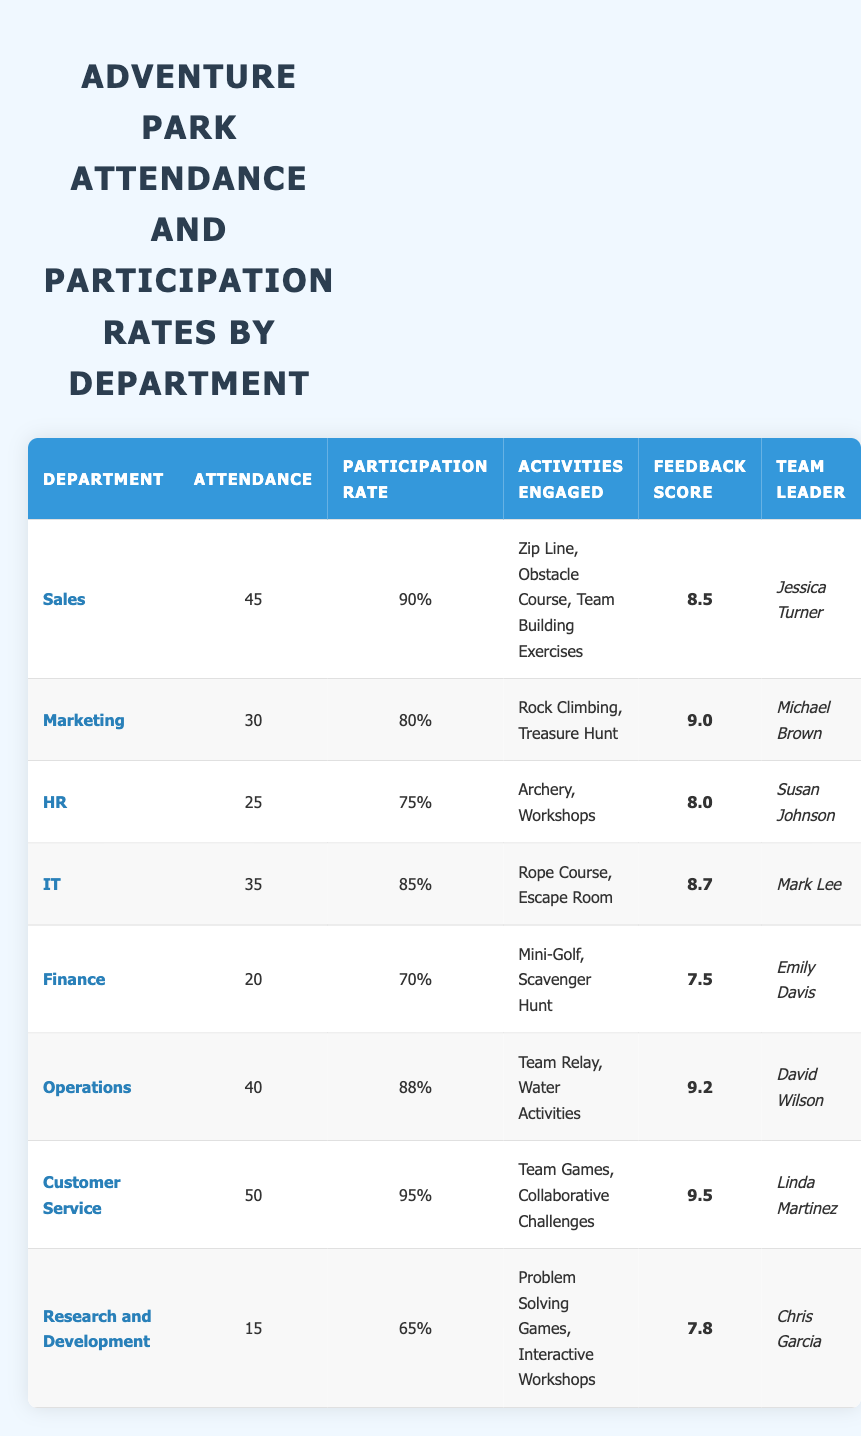What department had the highest attendance at the adventure park? The highest attendance can be found by looking at the "Attendance" column. Customer Service has 50, which is the highest among all departments.
Answer: Customer Service What is the participation rate of the HR department? The participation rate of the HR department is directly listed in the table under the "Participation Rate" column, which shows 75%.
Answer: 75% Which department received the highest feedback score? By checking the "Feedback Score" column, Customer Service has the highest score of 9.5, the only one above 9.0.
Answer: Customer Service How many total employees from the departments participated in the adventure park? To find the total number of employees, sum the "Attendance" values: 45 + 30 + 25 + 35 + 20 + 40 + 50 + 15 = 250.
Answer: 250 What is the average feedback score across all departments that attended the adventure park? First, sum the feedback scores (8.5 + 9.0 + 8.0 + 8.7 + 7.5 + 9.2 + 9.5 + 7.8 = 68.2) and divide by the number of departments (8). So, the average feedback score is 68.2 / 8 = 8.525.
Answer: 8.53 Is it true that the Operations department has a higher participation rate than the Finance department? Check the participation rates: Operations has 88% and Finance has 70%. 88% is greater than 70%, so the statement is true.
Answer: Yes What activities did the IT department engage in during their visit to the adventure park? The activities are listed for the IT department in the "Activities Engaged" column, which includes Rope Course and Escape Room.
Answer: Rope Course, Escape Room Which department had the lowest attendance, and what was their feedback score? By looking at the "Attendance" column, Research and Development had the lowest attendance with 15. Their feedback score is found in the same row, which is 7.8.
Answer: Research and Development, 7.8 If we wanted to find the participation difference between the department with the highest rate and the department with the lowest rate, what would that be? The highest participation rate is Customer Service at 95%, and the lowest is Research and Development at 65%. The difference is 95% - 65% = 30%.
Answer: 30% 